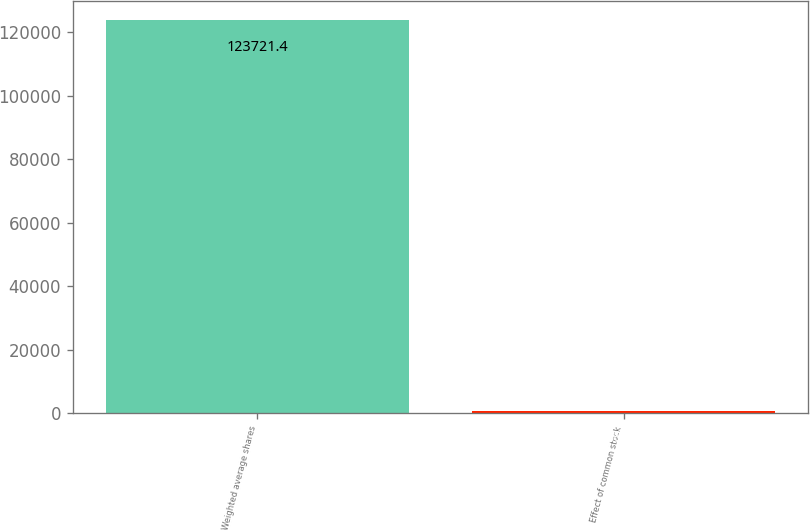<chart> <loc_0><loc_0><loc_500><loc_500><bar_chart><fcel>Weighted average shares<fcel>Effect of common stock<nl><fcel>123721<fcel>887<nl></chart> 